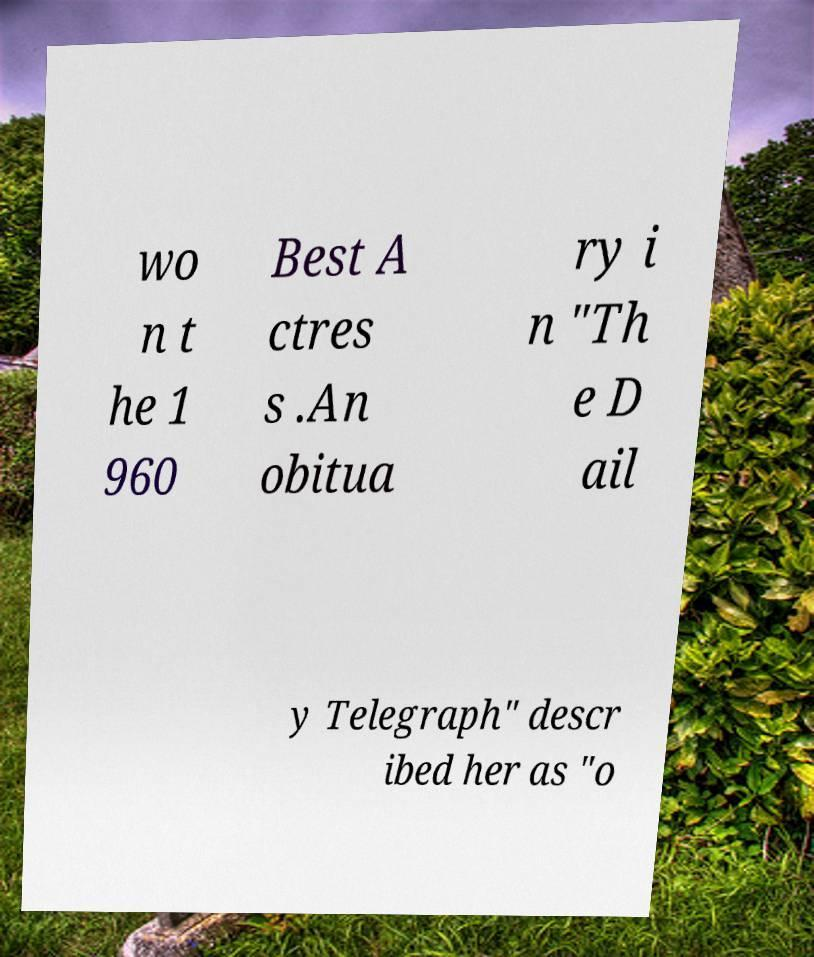For documentation purposes, I need the text within this image transcribed. Could you provide that? wo n t he 1 960 Best A ctres s .An obitua ry i n "Th e D ail y Telegraph" descr ibed her as "o 